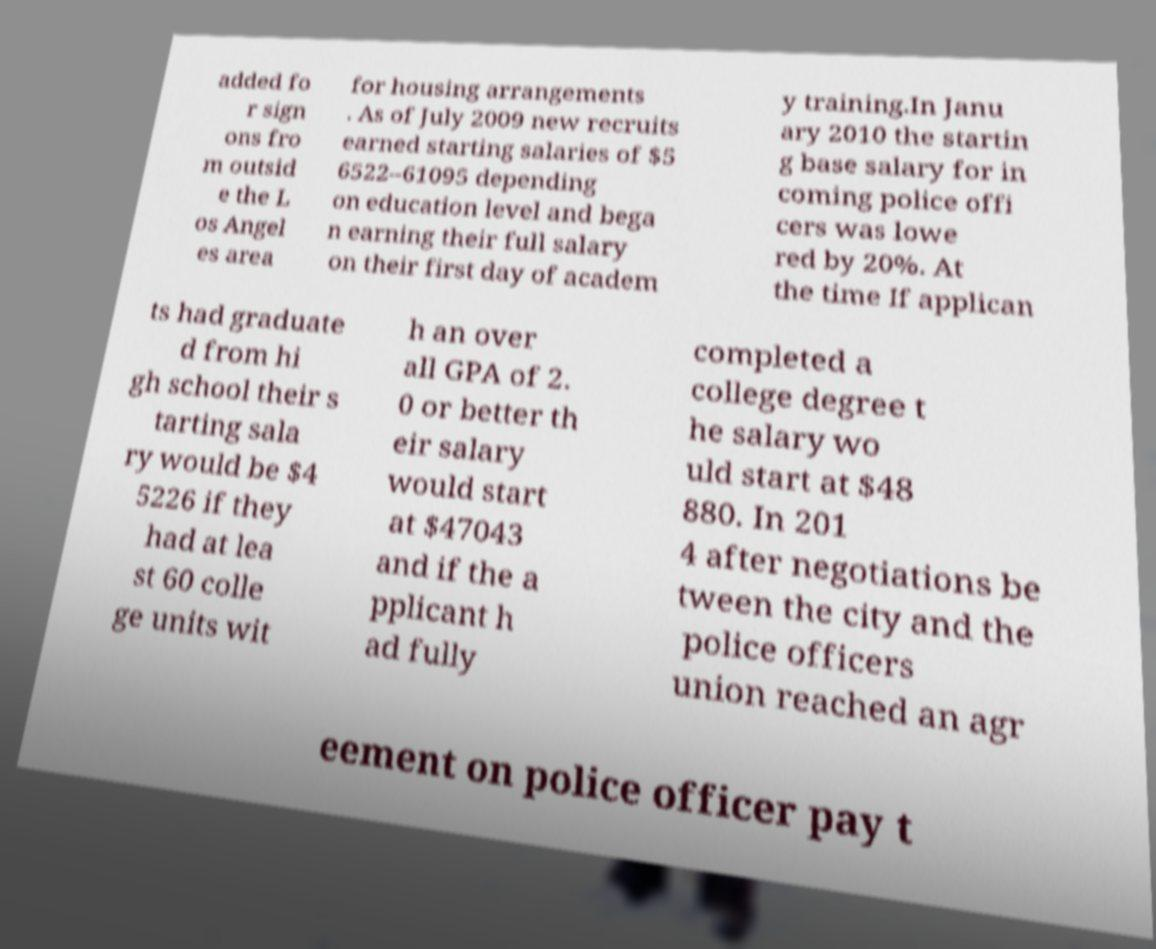Can you read and provide the text displayed in the image?This photo seems to have some interesting text. Can you extract and type it out for me? added fo r sign ons fro m outsid e the L os Angel es area for housing arrangements . As of July 2009 new recruits earned starting salaries of $5 6522–61095 depending on education level and bega n earning their full salary on their first day of academ y training.In Janu ary 2010 the startin g base salary for in coming police offi cers was lowe red by 20%. At the time If applican ts had graduate d from hi gh school their s tarting sala ry would be $4 5226 if they had at lea st 60 colle ge units wit h an over all GPA of 2. 0 or better th eir salary would start at $47043 and if the a pplicant h ad fully completed a college degree t he salary wo uld start at $48 880. In 201 4 after negotiations be tween the city and the police officers union reached an agr eement on police officer pay t 